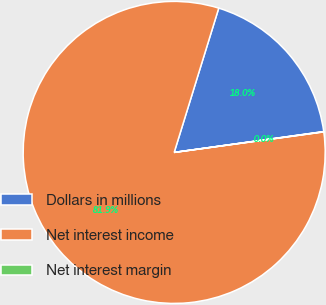<chart> <loc_0><loc_0><loc_500><loc_500><pie_chart><fcel>Dollars in millions<fcel>Net interest income<fcel>Net interest margin<nl><fcel>18.03%<fcel>81.94%<fcel>0.03%<nl></chart> 